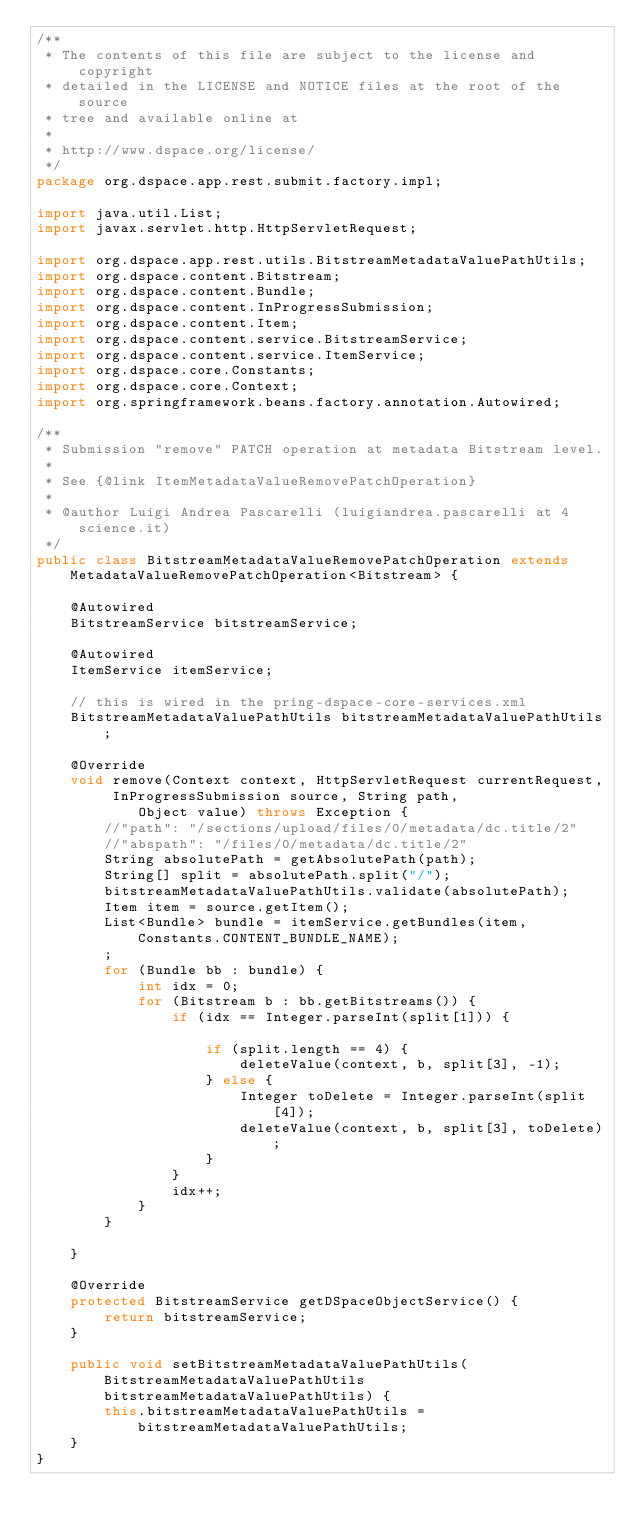Convert code to text. <code><loc_0><loc_0><loc_500><loc_500><_Java_>/**
 * The contents of this file are subject to the license and copyright
 * detailed in the LICENSE and NOTICE files at the root of the source
 * tree and available online at
 *
 * http://www.dspace.org/license/
 */
package org.dspace.app.rest.submit.factory.impl;

import java.util.List;
import javax.servlet.http.HttpServletRequest;

import org.dspace.app.rest.utils.BitstreamMetadataValuePathUtils;
import org.dspace.content.Bitstream;
import org.dspace.content.Bundle;
import org.dspace.content.InProgressSubmission;
import org.dspace.content.Item;
import org.dspace.content.service.BitstreamService;
import org.dspace.content.service.ItemService;
import org.dspace.core.Constants;
import org.dspace.core.Context;
import org.springframework.beans.factory.annotation.Autowired;

/**
 * Submission "remove" PATCH operation at metadata Bitstream level.
 *
 * See {@link ItemMetadataValueRemovePatchOperation}
 *
 * @author Luigi Andrea Pascarelli (luigiandrea.pascarelli at 4science.it)
 */
public class BitstreamMetadataValueRemovePatchOperation extends MetadataValueRemovePatchOperation<Bitstream> {

    @Autowired
    BitstreamService bitstreamService;

    @Autowired
    ItemService itemService;

    // this is wired in the pring-dspace-core-services.xml
    BitstreamMetadataValuePathUtils bitstreamMetadataValuePathUtils;

    @Override
    void remove(Context context, HttpServletRequest currentRequest, InProgressSubmission source, String path,
            Object value) throws Exception {
        //"path": "/sections/upload/files/0/metadata/dc.title/2"
        //"abspath": "/files/0/metadata/dc.title/2"
        String absolutePath = getAbsolutePath(path);
        String[] split = absolutePath.split("/");
        bitstreamMetadataValuePathUtils.validate(absolutePath);
        Item item = source.getItem();
        List<Bundle> bundle = itemService.getBundles(item, Constants.CONTENT_BUNDLE_NAME);
        ;
        for (Bundle bb : bundle) {
            int idx = 0;
            for (Bitstream b : bb.getBitstreams()) {
                if (idx == Integer.parseInt(split[1])) {

                    if (split.length == 4) {
                        deleteValue(context, b, split[3], -1);
                    } else {
                        Integer toDelete = Integer.parseInt(split[4]);
                        deleteValue(context, b, split[3], toDelete);
                    }
                }
                idx++;
            }
        }

    }

    @Override
    protected BitstreamService getDSpaceObjectService() {
        return bitstreamService;
    }

    public void setBitstreamMetadataValuePathUtils(BitstreamMetadataValuePathUtils bitstreamMetadataValuePathUtils) {
        this.bitstreamMetadataValuePathUtils = bitstreamMetadataValuePathUtils;
    }
}
</code> 